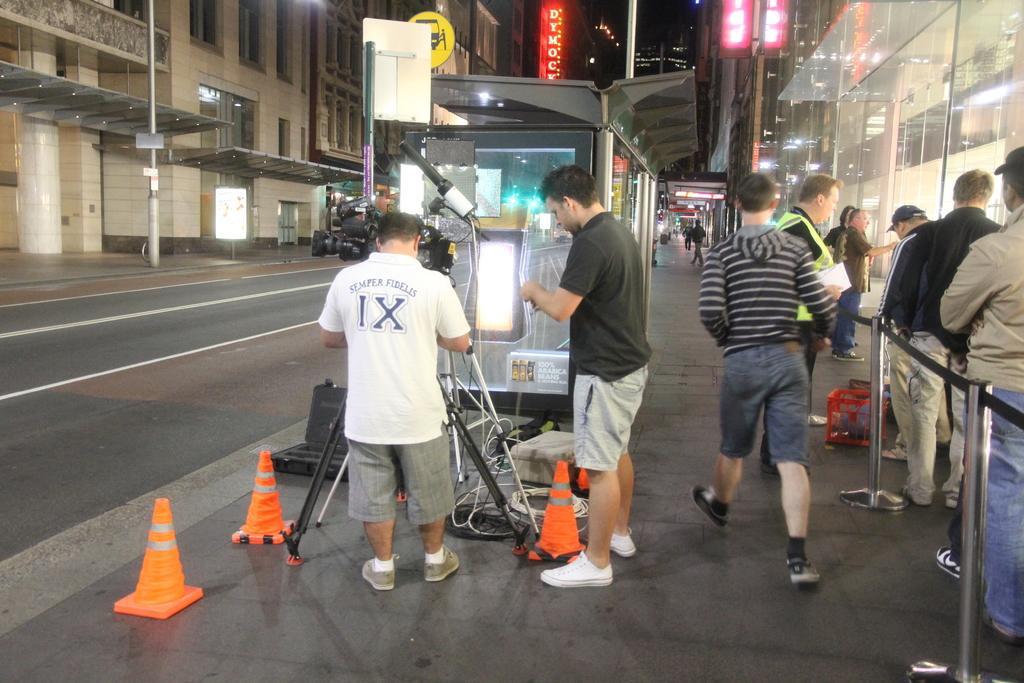How would you summarize this image in a sentence or two? Here in this picture we can see number of people standing and walking on the road and in the front we can see a video camera kept on a tripod and we can also see lights present and beside that we can see a shed present and on the right side we can see a Q manager present on the road and on either side of it we can see buildings present and we can also see hoardings and we can see light posts present. 